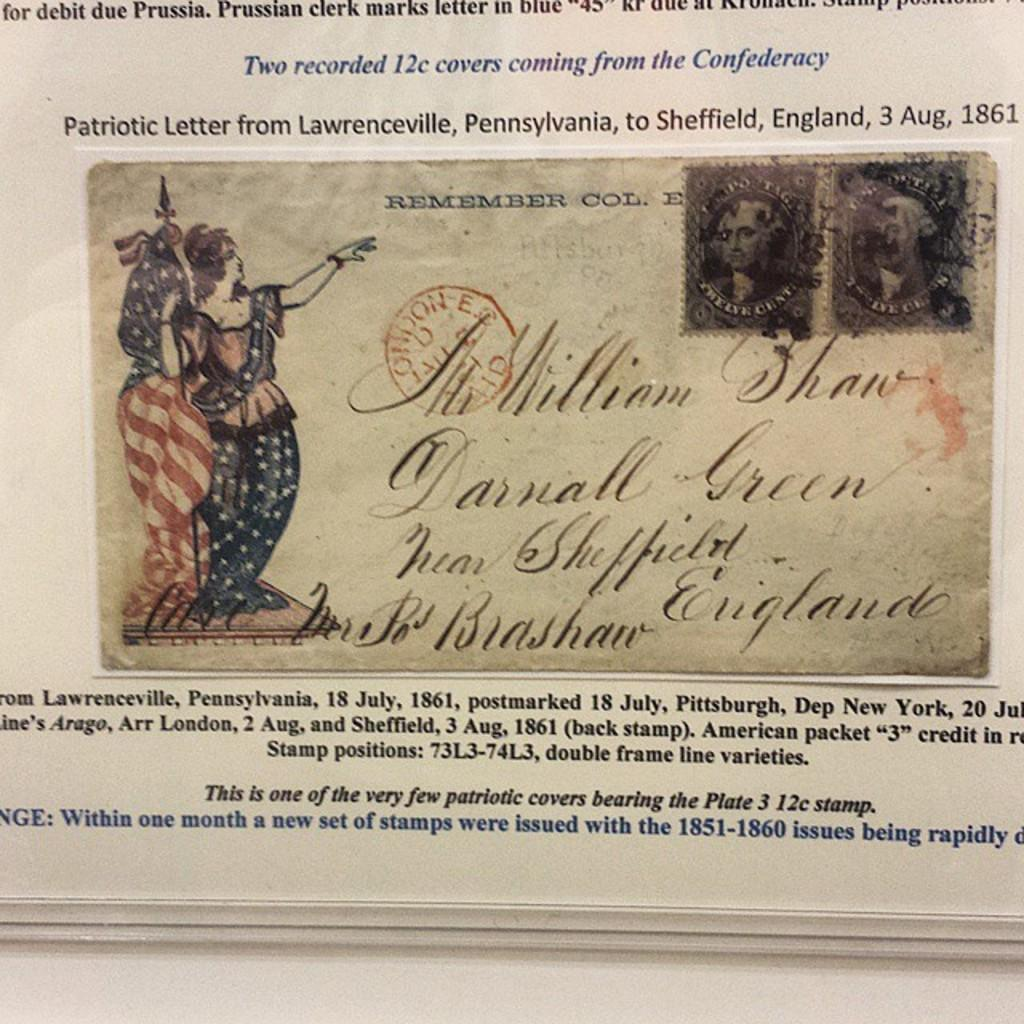What type of image is being described? The image is a poster. What can be seen on the poster? There are depictions of persons on the poster. Are there any words on the poster? Yes, there is text on the poster. Can you tell me how many basketballs are shown on the poster? There is no mention of basketballs in the provided facts, so it cannot be determined if any are present on the poster. 